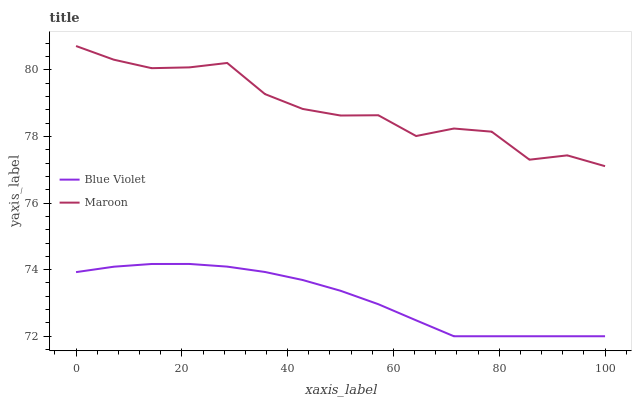Does Blue Violet have the maximum area under the curve?
Answer yes or no. No. Is Blue Violet the roughest?
Answer yes or no. No. Does Blue Violet have the highest value?
Answer yes or no. No. Is Blue Violet less than Maroon?
Answer yes or no. Yes. Is Maroon greater than Blue Violet?
Answer yes or no. Yes. Does Blue Violet intersect Maroon?
Answer yes or no. No. 